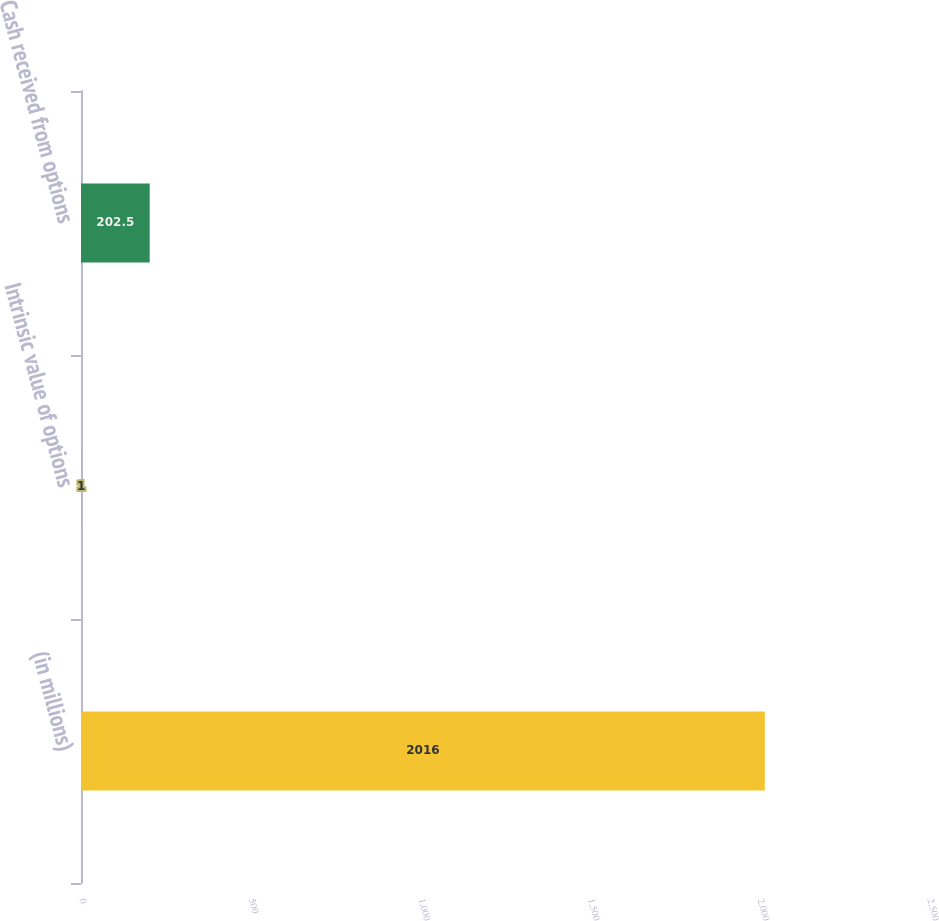<chart> <loc_0><loc_0><loc_500><loc_500><bar_chart><fcel>(in millions)<fcel>Intrinsic value of options<fcel>Cash received from options<nl><fcel>2016<fcel>1<fcel>202.5<nl></chart> 